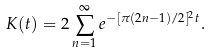Convert formula to latex. <formula><loc_0><loc_0><loc_500><loc_500>K ( t ) & = 2 \sum _ { n = 1 } ^ { \infty } e ^ { - [ \pi ( 2 n - 1 ) / 2 ] ^ { 2 } t } .</formula> 